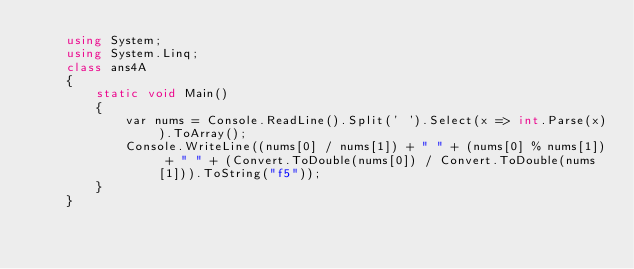Convert code to text. <code><loc_0><loc_0><loc_500><loc_500><_C#_>    using System;
    using System.Linq;
    class ans4A
    {
        static void Main()
        {
            var nums = Console.ReadLine().Split(' ').Select(x => int.Parse(x)).ToArray();
            Console.WriteLine((nums[0] / nums[1]) + " " + (nums[0] % nums[1]) + " " + (Convert.ToDouble(nums[0]) / Convert.ToDouble(nums[1])).ToString("f5"));
        }
    }
</code> 